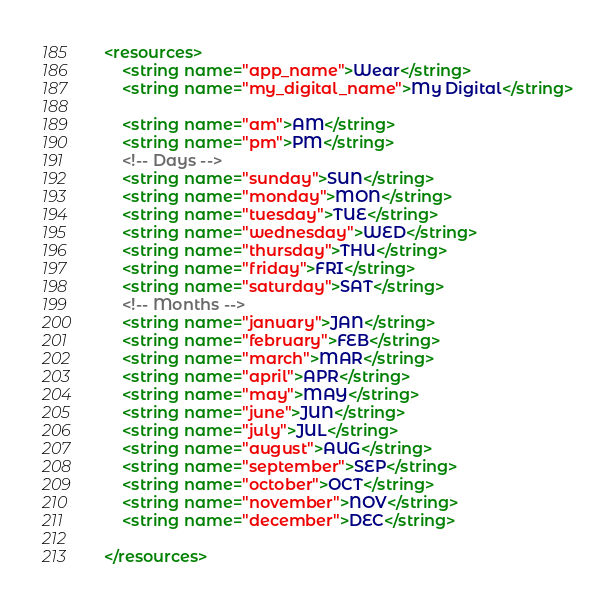Convert code to text. <code><loc_0><loc_0><loc_500><loc_500><_XML_><resources>
    <string name="app_name">Wear</string>
    <string name="my_digital_name">My Digital</string>

    <string name="am">AM</string>
    <string name="pm">PM</string>
    <!-- Days -->
    <string name="sunday">SUN</string>
    <string name="monday">MON</string>
    <string name="tuesday">TUE</string>
    <string name="wednesday">WED</string>
    <string name="thursday">THU</string>
    <string name="friday">FRI</string>
    <string name="saturday">SAT</string>
    <!-- Months -->
    <string name="january">JAN</string>
    <string name="february">FEB</string>
    <string name="march">MAR</string>
    <string name="april">APR</string>
    <string name="may">MAY</string>
    <string name="june">JUN</string>
    <string name="july">JUL</string>
    <string name="august">AUG</string>
    <string name="september">SEP</string>
    <string name="october">OCT</string>
    <string name="november">NOV</string>
    <string name="december">DEC</string>

</resources>
</code> 